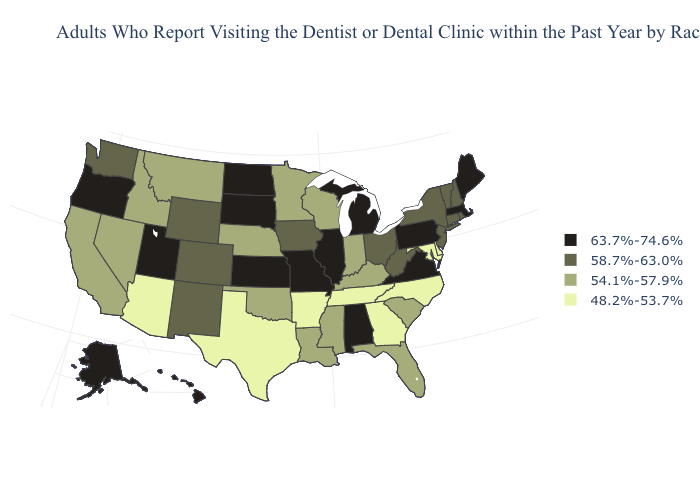Among the states that border Alabama , does Florida have the highest value?
Keep it brief. Yes. Is the legend a continuous bar?
Concise answer only. No. Among the states that border Montana , does South Dakota have the lowest value?
Concise answer only. No. Which states have the lowest value in the USA?
Short answer required. Arizona, Arkansas, Delaware, Georgia, Maryland, North Carolina, Tennessee, Texas. What is the highest value in states that border Colorado?
Write a very short answer. 63.7%-74.6%. Name the states that have a value in the range 48.2%-53.7%?
Be succinct. Arizona, Arkansas, Delaware, Georgia, Maryland, North Carolina, Tennessee, Texas. What is the value of Wyoming?
Answer briefly. 58.7%-63.0%. Name the states that have a value in the range 63.7%-74.6%?
Give a very brief answer. Alabama, Alaska, Hawaii, Illinois, Kansas, Maine, Massachusetts, Michigan, Missouri, North Dakota, Oregon, Pennsylvania, South Dakota, Utah, Virginia. Which states have the lowest value in the USA?
Write a very short answer. Arizona, Arkansas, Delaware, Georgia, Maryland, North Carolina, Tennessee, Texas. What is the lowest value in the Northeast?
Quick response, please. 58.7%-63.0%. What is the lowest value in the South?
Be succinct. 48.2%-53.7%. Name the states that have a value in the range 63.7%-74.6%?
Concise answer only. Alabama, Alaska, Hawaii, Illinois, Kansas, Maine, Massachusetts, Michigan, Missouri, North Dakota, Oregon, Pennsylvania, South Dakota, Utah, Virginia. What is the value of Indiana?
Quick response, please. 54.1%-57.9%. Among the states that border California , does Oregon have the lowest value?
Short answer required. No. What is the value of Tennessee?
Answer briefly. 48.2%-53.7%. 